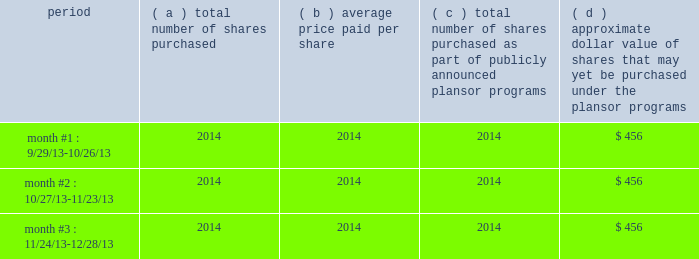Part ii item 5 .
Market for the registrant 2019s common equity , related stockholder matters and issuer purchases of equity securities information on the market for our common stock , number of shareowners and dividends is located in note 15 within notes to consolidated financial statements .
In december 2012 , our board of directors approved a share repurchase program authorizing us to repurchase shares of our common stock amounting to $ 300 million during 2013 .
On april 26 , 2013 , the board of directors approved an authorization to repurchase up to $ 1 billion in shares through april 2014 .
In february 2014 , the board of directors approved a new authorization to repurchase up to $ 1.5 billion in shares through december 2015 .
This authorization supersedes the april 2013 authorization and is intended to allow us to repurchase shares for general corporate purposes and to offset issuances for employee benefit programs .
During 2013 , the company repurchased approximately 9 million shares for a total of $ 544 million .
The table provides information with respect to purchases of common shares under programs authorized by our board of directors during the quarter ended december 28 , 2013 .
( millions , except per share data ) period number shares purchased average paid per number of shares purchased as part of publicly announced plans or programs approximate dollar value of shares that may yet be purchased under the plans or programs month #1 : 9/29/13-10/26/13 2014 2014 2014 $ 456 month #2 : 10/27/13-11/23/13 2014 2014 2014 $ 456 month #3 : 11/24/13-12/28/13 2014 2014 2014 $ 456 .
Part ii item 5 .
Market for the registrant 2019s common equity , related stockholder matters and issuer purchases of equity securities information on the market for our common stock , number of shareowners and dividends is located in note 15 within notes to consolidated financial statements .
In december 2012 , our board of directors approved a share repurchase program authorizing us to repurchase shares of our common stock amounting to $ 300 million during 2013 .
On april 26 , 2013 , the board of directors approved an authorization to repurchase up to $ 1 billion in shares through april 2014 .
In february 2014 , the board of directors approved a new authorization to repurchase up to $ 1.5 billion in shares through december 2015 .
This authorization supersedes the april 2013 authorization and is intended to allow us to repurchase shares for general corporate purposes and to offset issuances for employee benefit programs .
During 2013 , the company repurchased approximately 9 million shares for a total of $ 544 million .
The following table provides information with respect to purchases of common shares under programs authorized by our board of directors during the quarter ended december 28 , 2013 .
( millions , except per share data ) period number shares purchased average paid per number of shares purchased as part of publicly announced plans or programs approximate dollar value of shares that may yet be purchased under the plans or programs month #1 : 9/29/13-10/26/13 2014 2014 2014 $ 456 month #2 : 10/27/13-11/23/13 2014 2014 2014 $ 456 month #3 : 11/24/13-12/28/13 2014 2014 2014 $ 456 .
What was the average share price in 2013? ( $ )? 
Computations: (544 / 9)
Answer: 60.44444. 